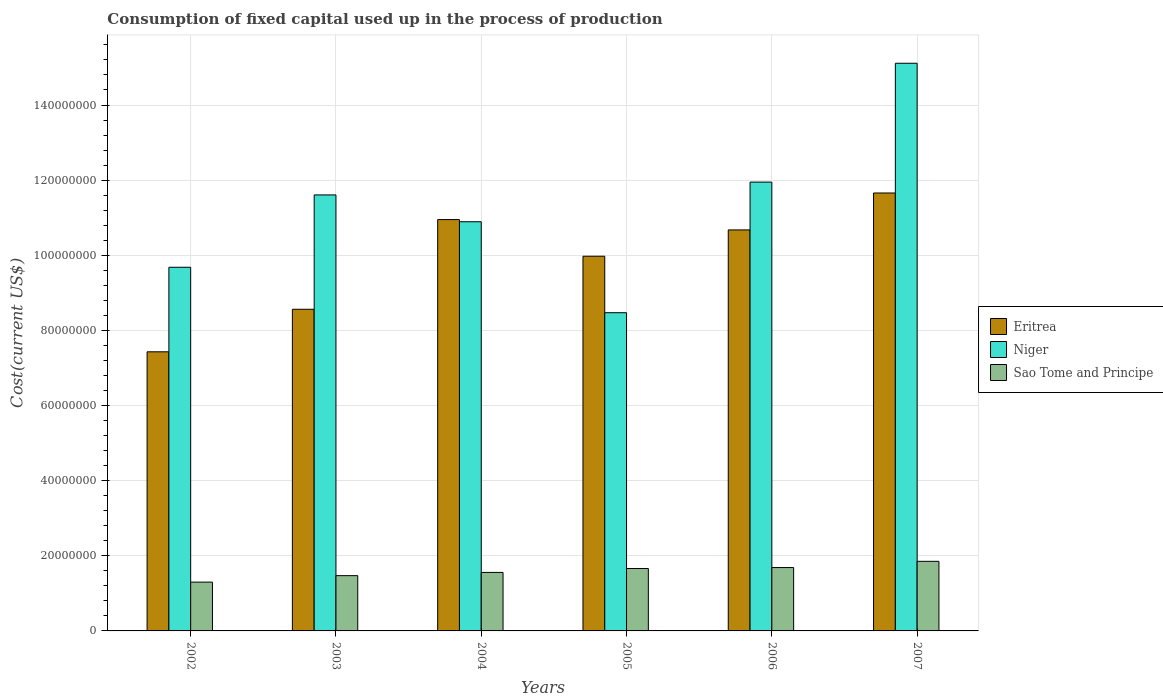How many bars are there on the 4th tick from the left?
Provide a succinct answer. 3. In how many cases, is the number of bars for a given year not equal to the number of legend labels?
Give a very brief answer. 0. What is the amount consumed in the process of production in Eritrea in 2002?
Provide a short and direct response. 7.43e+07. Across all years, what is the maximum amount consumed in the process of production in Eritrea?
Provide a short and direct response. 1.17e+08. Across all years, what is the minimum amount consumed in the process of production in Niger?
Offer a terse response. 8.47e+07. What is the total amount consumed in the process of production in Eritrea in the graph?
Ensure brevity in your answer.  5.93e+08. What is the difference between the amount consumed in the process of production in Sao Tome and Principe in 2005 and that in 2007?
Your answer should be compact. -1.92e+06. What is the difference between the amount consumed in the process of production in Eritrea in 2006 and the amount consumed in the process of production in Niger in 2004?
Offer a terse response. -2.17e+06. What is the average amount consumed in the process of production in Niger per year?
Offer a terse response. 1.13e+08. In the year 2003, what is the difference between the amount consumed in the process of production in Niger and amount consumed in the process of production in Sao Tome and Principe?
Your answer should be compact. 1.01e+08. In how many years, is the amount consumed in the process of production in Niger greater than 72000000 US$?
Your answer should be compact. 6. What is the ratio of the amount consumed in the process of production in Niger in 2004 to that in 2007?
Offer a terse response. 0.72. Is the amount consumed in the process of production in Niger in 2003 less than that in 2006?
Your answer should be very brief. Yes. Is the difference between the amount consumed in the process of production in Niger in 2003 and 2007 greater than the difference between the amount consumed in the process of production in Sao Tome and Principe in 2003 and 2007?
Keep it short and to the point. No. What is the difference between the highest and the second highest amount consumed in the process of production in Sao Tome and Principe?
Your answer should be compact. 1.66e+06. What is the difference between the highest and the lowest amount consumed in the process of production in Eritrea?
Ensure brevity in your answer.  4.23e+07. In how many years, is the amount consumed in the process of production in Eritrea greater than the average amount consumed in the process of production in Eritrea taken over all years?
Offer a terse response. 4. Is the sum of the amount consumed in the process of production in Sao Tome and Principe in 2002 and 2007 greater than the maximum amount consumed in the process of production in Niger across all years?
Your answer should be compact. No. What does the 3rd bar from the left in 2005 represents?
Make the answer very short. Sao Tome and Principe. What does the 2nd bar from the right in 2004 represents?
Provide a succinct answer. Niger. Is it the case that in every year, the sum of the amount consumed in the process of production in Eritrea and amount consumed in the process of production in Sao Tome and Principe is greater than the amount consumed in the process of production in Niger?
Keep it short and to the point. No. How many years are there in the graph?
Give a very brief answer. 6. Are the values on the major ticks of Y-axis written in scientific E-notation?
Give a very brief answer. No. Does the graph contain grids?
Offer a terse response. Yes. How many legend labels are there?
Offer a very short reply. 3. What is the title of the graph?
Give a very brief answer. Consumption of fixed capital used up in the process of production. Does "Kosovo" appear as one of the legend labels in the graph?
Your answer should be very brief. No. What is the label or title of the X-axis?
Keep it short and to the point. Years. What is the label or title of the Y-axis?
Ensure brevity in your answer.  Cost(current US$). What is the Cost(current US$) of Eritrea in 2002?
Make the answer very short. 7.43e+07. What is the Cost(current US$) of Niger in 2002?
Keep it short and to the point. 9.68e+07. What is the Cost(current US$) of Sao Tome and Principe in 2002?
Keep it short and to the point. 1.30e+07. What is the Cost(current US$) of Eritrea in 2003?
Your answer should be very brief. 8.56e+07. What is the Cost(current US$) in Niger in 2003?
Provide a succinct answer. 1.16e+08. What is the Cost(current US$) in Sao Tome and Principe in 2003?
Give a very brief answer. 1.47e+07. What is the Cost(current US$) of Eritrea in 2004?
Your answer should be compact. 1.10e+08. What is the Cost(current US$) of Niger in 2004?
Your answer should be compact. 1.09e+08. What is the Cost(current US$) of Sao Tome and Principe in 2004?
Provide a succinct answer. 1.56e+07. What is the Cost(current US$) of Eritrea in 2005?
Your answer should be very brief. 9.97e+07. What is the Cost(current US$) of Niger in 2005?
Keep it short and to the point. 8.47e+07. What is the Cost(current US$) in Sao Tome and Principe in 2005?
Keep it short and to the point. 1.66e+07. What is the Cost(current US$) in Eritrea in 2006?
Offer a terse response. 1.07e+08. What is the Cost(current US$) of Niger in 2006?
Your answer should be very brief. 1.19e+08. What is the Cost(current US$) in Sao Tome and Principe in 2006?
Your answer should be very brief. 1.69e+07. What is the Cost(current US$) in Eritrea in 2007?
Make the answer very short. 1.17e+08. What is the Cost(current US$) of Niger in 2007?
Give a very brief answer. 1.51e+08. What is the Cost(current US$) in Sao Tome and Principe in 2007?
Keep it short and to the point. 1.85e+07. Across all years, what is the maximum Cost(current US$) in Eritrea?
Keep it short and to the point. 1.17e+08. Across all years, what is the maximum Cost(current US$) of Niger?
Your response must be concise. 1.51e+08. Across all years, what is the maximum Cost(current US$) of Sao Tome and Principe?
Give a very brief answer. 1.85e+07. Across all years, what is the minimum Cost(current US$) of Eritrea?
Offer a terse response. 7.43e+07. Across all years, what is the minimum Cost(current US$) of Niger?
Offer a terse response. 8.47e+07. Across all years, what is the minimum Cost(current US$) in Sao Tome and Principe?
Keep it short and to the point. 1.30e+07. What is the total Cost(current US$) of Eritrea in the graph?
Offer a very short reply. 5.93e+08. What is the total Cost(current US$) of Niger in the graph?
Your response must be concise. 6.77e+08. What is the total Cost(current US$) in Sao Tome and Principe in the graph?
Your answer should be compact. 9.53e+07. What is the difference between the Cost(current US$) in Eritrea in 2002 and that in 2003?
Your answer should be very brief. -1.13e+07. What is the difference between the Cost(current US$) in Niger in 2002 and that in 2003?
Your answer should be compact. -1.93e+07. What is the difference between the Cost(current US$) of Sao Tome and Principe in 2002 and that in 2003?
Your answer should be very brief. -1.72e+06. What is the difference between the Cost(current US$) in Eritrea in 2002 and that in 2004?
Provide a short and direct response. -3.52e+07. What is the difference between the Cost(current US$) of Niger in 2002 and that in 2004?
Your answer should be compact. -1.21e+07. What is the difference between the Cost(current US$) of Sao Tome and Principe in 2002 and that in 2004?
Give a very brief answer. -2.58e+06. What is the difference between the Cost(current US$) of Eritrea in 2002 and that in 2005?
Offer a terse response. -2.54e+07. What is the difference between the Cost(current US$) in Niger in 2002 and that in 2005?
Provide a short and direct response. 1.21e+07. What is the difference between the Cost(current US$) in Sao Tome and Principe in 2002 and that in 2005?
Your answer should be very brief. -3.62e+06. What is the difference between the Cost(current US$) in Eritrea in 2002 and that in 2006?
Your answer should be very brief. -3.25e+07. What is the difference between the Cost(current US$) of Niger in 2002 and that in 2006?
Your response must be concise. -2.27e+07. What is the difference between the Cost(current US$) of Sao Tome and Principe in 2002 and that in 2006?
Provide a succinct answer. -3.87e+06. What is the difference between the Cost(current US$) in Eritrea in 2002 and that in 2007?
Your response must be concise. -4.23e+07. What is the difference between the Cost(current US$) in Niger in 2002 and that in 2007?
Provide a short and direct response. -5.43e+07. What is the difference between the Cost(current US$) of Sao Tome and Principe in 2002 and that in 2007?
Your answer should be very brief. -5.54e+06. What is the difference between the Cost(current US$) in Eritrea in 2003 and that in 2004?
Make the answer very short. -2.39e+07. What is the difference between the Cost(current US$) in Niger in 2003 and that in 2004?
Give a very brief answer. 7.14e+06. What is the difference between the Cost(current US$) of Sao Tome and Principe in 2003 and that in 2004?
Provide a short and direct response. -8.62e+05. What is the difference between the Cost(current US$) in Eritrea in 2003 and that in 2005?
Give a very brief answer. -1.41e+07. What is the difference between the Cost(current US$) in Niger in 2003 and that in 2005?
Provide a short and direct response. 3.14e+07. What is the difference between the Cost(current US$) in Sao Tome and Principe in 2003 and that in 2005?
Provide a succinct answer. -1.90e+06. What is the difference between the Cost(current US$) of Eritrea in 2003 and that in 2006?
Ensure brevity in your answer.  -2.11e+07. What is the difference between the Cost(current US$) of Niger in 2003 and that in 2006?
Provide a succinct answer. -3.42e+06. What is the difference between the Cost(current US$) of Sao Tome and Principe in 2003 and that in 2006?
Keep it short and to the point. -2.15e+06. What is the difference between the Cost(current US$) of Eritrea in 2003 and that in 2007?
Give a very brief answer. -3.10e+07. What is the difference between the Cost(current US$) in Niger in 2003 and that in 2007?
Your response must be concise. -3.51e+07. What is the difference between the Cost(current US$) in Sao Tome and Principe in 2003 and that in 2007?
Your answer should be very brief. -3.81e+06. What is the difference between the Cost(current US$) in Eritrea in 2004 and that in 2005?
Provide a short and direct response. 9.75e+06. What is the difference between the Cost(current US$) in Niger in 2004 and that in 2005?
Your answer should be compact. 2.42e+07. What is the difference between the Cost(current US$) in Sao Tome and Principe in 2004 and that in 2005?
Your answer should be compact. -1.04e+06. What is the difference between the Cost(current US$) of Eritrea in 2004 and that in 2006?
Your response must be concise. 2.75e+06. What is the difference between the Cost(current US$) of Niger in 2004 and that in 2006?
Your answer should be compact. -1.06e+07. What is the difference between the Cost(current US$) in Sao Tome and Principe in 2004 and that in 2006?
Make the answer very short. -1.29e+06. What is the difference between the Cost(current US$) of Eritrea in 2004 and that in 2007?
Your answer should be compact. -7.08e+06. What is the difference between the Cost(current US$) in Niger in 2004 and that in 2007?
Provide a succinct answer. -4.22e+07. What is the difference between the Cost(current US$) in Sao Tome and Principe in 2004 and that in 2007?
Give a very brief answer. -2.95e+06. What is the difference between the Cost(current US$) of Eritrea in 2005 and that in 2006?
Make the answer very short. -7.01e+06. What is the difference between the Cost(current US$) of Niger in 2005 and that in 2006?
Ensure brevity in your answer.  -3.48e+07. What is the difference between the Cost(current US$) of Sao Tome and Principe in 2005 and that in 2006?
Make the answer very short. -2.56e+05. What is the difference between the Cost(current US$) in Eritrea in 2005 and that in 2007?
Offer a very short reply. -1.68e+07. What is the difference between the Cost(current US$) in Niger in 2005 and that in 2007?
Keep it short and to the point. -6.64e+07. What is the difference between the Cost(current US$) of Sao Tome and Principe in 2005 and that in 2007?
Your answer should be very brief. -1.92e+06. What is the difference between the Cost(current US$) in Eritrea in 2006 and that in 2007?
Your answer should be compact. -9.83e+06. What is the difference between the Cost(current US$) of Niger in 2006 and that in 2007?
Give a very brief answer. -3.16e+07. What is the difference between the Cost(current US$) of Sao Tome and Principe in 2006 and that in 2007?
Your response must be concise. -1.66e+06. What is the difference between the Cost(current US$) of Eritrea in 2002 and the Cost(current US$) of Niger in 2003?
Give a very brief answer. -4.18e+07. What is the difference between the Cost(current US$) in Eritrea in 2002 and the Cost(current US$) in Sao Tome and Principe in 2003?
Ensure brevity in your answer.  5.96e+07. What is the difference between the Cost(current US$) in Niger in 2002 and the Cost(current US$) in Sao Tome and Principe in 2003?
Offer a very short reply. 8.21e+07. What is the difference between the Cost(current US$) in Eritrea in 2002 and the Cost(current US$) in Niger in 2004?
Ensure brevity in your answer.  -3.46e+07. What is the difference between the Cost(current US$) in Eritrea in 2002 and the Cost(current US$) in Sao Tome and Principe in 2004?
Provide a succinct answer. 5.87e+07. What is the difference between the Cost(current US$) in Niger in 2002 and the Cost(current US$) in Sao Tome and Principe in 2004?
Provide a succinct answer. 8.12e+07. What is the difference between the Cost(current US$) in Eritrea in 2002 and the Cost(current US$) in Niger in 2005?
Offer a terse response. -1.04e+07. What is the difference between the Cost(current US$) of Eritrea in 2002 and the Cost(current US$) of Sao Tome and Principe in 2005?
Your answer should be very brief. 5.77e+07. What is the difference between the Cost(current US$) of Niger in 2002 and the Cost(current US$) of Sao Tome and Principe in 2005?
Provide a short and direct response. 8.02e+07. What is the difference between the Cost(current US$) of Eritrea in 2002 and the Cost(current US$) of Niger in 2006?
Your response must be concise. -4.52e+07. What is the difference between the Cost(current US$) of Eritrea in 2002 and the Cost(current US$) of Sao Tome and Principe in 2006?
Your response must be concise. 5.74e+07. What is the difference between the Cost(current US$) in Niger in 2002 and the Cost(current US$) in Sao Tome and Principe in 2006?
Offer a terse response. 7.99e+07. What is the difference between the Cost(current US$) of Eritrea in 2002 and the Cost(current US$) of Niger in 2007?
Your response must be concise. -7.68e+07. What is the difference between the Cost(current US$) in Eritrea in 2002 and the Cost(current US$) in Sao Tome and Principe in 2007?
Keep it short and to the point. 5.58e+07. What is the difference between the Cost(current US$) of Niger in 2002 and the Cost(current US$) of Sao Tome and Principe in 2007?
Offer a very short reply. 7.83e+07. What is the difference between the Cost(current US$) in Eritrea in 2003 and the Cost(current US$) in Niger in 2004?
Make the answer very short. -2.33e+07. What is the difference between the Cost(current US$) in Eritrea in 2003 and the Cost(current US$) in Sao Tome and Principe in 2004?
Provide a succinct answer. 7.01e+07. What is the difference between the Cost(current US$) of Niger in 2003 and the Cost(current US$) of Sao Tome and Principe in 2004?
Your response must be concise. 1.00e+08. What is the difference between the Cost(current US$) in Eritrea in 2003 and the Cost(current US$) in Niger in 2005?
Make the answer very short. 9.17e+05. What is the difference between the Cost(current US$) of Eritrea in 2003 and the Cost(current US$) of Sao Tome and Principe in 2005?
Offer a terse response. 6.90e+07. What is the difference between the Cost(current US$) in Niger in 2003 and the Cost(current US$) in Sao Tome and Principe in 2005?
Offer a terse response. 9.95e+07. What is the difference between the Cost(current US$) in Eritrea in 2003 and the Cost(current US$) in Niger in 2006?
Make the answer very short. -3.39e+07. What is the difference between the Cost(current US$) of Eritrea in 2003 and the Cost(current US$) of Sao Tome and Principe in 2006?
Provide a succinct answer. 6.88e+07. What is the difference between the Cost(current US$) of Niger in 2003 and the Cost(current US$) of Sao Tome and Principe in 2006?
Make the answer very short. 9.92e+07. What is the difference between the Cost(current US$) of Eritrea in 2003 and the Cost(current US$) of Niger in 2007?
Your answer should be compact. -6.55e+07. What is the difference between the Cost(current US$) of Eritrea in 2003 and the Cost(current US$) of Sao Tome and Principe in 2007?
Your answer should be compact. 6.71e+07. What is the difference between the Cost(current US$) of Niger in 2003 and the Cost(current US$) of Sao Tome and Principe in 2007?
Provide a succinct answer. 9.75e+07. What is the difference between the Cost(current US$) in Eritrea in 2004 and the Cost(current US$) in Niger in 2005?
Keep it short and to the point. 2.48e+07. What is the difference between the Cost(current US$) of Eritrea in 2004 and the Cost(current US$) of Sao Tome and Principe in 2005?
Your answer should be compact. 9.29e+07. What is the difference between the Cost(current US$) of Niger in 2004 and the Cost(current US$) of Sao Tome and Principe in 2005?
Ensure brevity in your answer.  9.23e+07. What is the difference between the Cost(current US$) in Eritrea in 2004 and the Cost(current US$) in Niger in 2006?
Your answer should be compact. -9.98e+06. What is the difference between the Cost(current US$) in Eritrea in 2004 and the Cost(current US$) in Sao Tome and Principe in 2006?
Ensure brevity in your answer.  9.26e+07. What is the difference between the Cost(current US$) in Niger in 2004 and the Cost(current US$) in Sao Tome and Principe in 2006?
Offer a terse response. 9.21e+07. What is the difference between the Cost(current US$) of Eritrea in 2004 and the Cost(current US$) of Niger in 2007?
Your answer should be very brief. -4.16e+07. What is the difference between the Cost(current US$) in Eritrea in 2004 and the Cost(current US$) in Sao Tome and Principe in 2007?
Offer a terse response. 9.10e+07. What is the difference between the Cost(current US$) of Niger in 2004 and the Cost(current US$) of Sao Tome and Principe in 2007?
Keep it short and to the point. 9.04e+07. What is the difference between the Cost(current US$) in Eritrea in 2005 and the Cost(current US$) in Niger in 2006?
Make the answer very short. -1.97e+07. What is the difference between the Cost(current US$) in Eritrea in 2005 and the Cost(current US$) in Sao Tome and Principe in 2006?
Ensure brevity in your answer.  8.29e+07. What is the difference between the Cost(current US$) in Niger in 2005 and the Cost(current US$) in Sao Tome and Principe in 2006?
Your response must be concise. 6.78e+07. What is the difference between the Cost(current US$) in Eritrea in 2005 and the Cost(current US$) in Niger in 2007?
Make the answer very short. -5.14e+07. What is the difference between the Cost(current US$) of Eritrea in 2005 and the Cost(current US$) of Sao Tome and Principe in 2007?
Keep it short and to the point. 8.12e+07. What is the difference between the Cost(current US$) in Niger in 2005 and the Cost(current US$) in Sao Tome and Principe in 2007?
Your answer should be very brief. 6.62e+07. What is the difference between the Cost(current US$) in Eritrea in 2006 and the Cost(current US$) in Niger in 2007?
Your answer should be compact. -4.44e+07. What is the difference between the Cost(current US$) of Eritrea in 2006 and the Cost(current US$) of Sao Tome and Principe in 2007?
Offer a very short reply. 8.82e+07. What is the difference between the Cost(current US$) in Niger in 2006 and the Cost(current US$) in Sao Tome and Principe in 2007?
Your answer should be very brief. 1.01e+08. What is the average Cost(current US$) of Eritrea per year?
Offer a very short reply. 9.88e+07. What is the average Cost(current US$) in Niger per year?
Your answer should be compact. 1.13e+08. What is the average Cost(current US$) in Sao Tome and Principe per year?
Offer a very short reply. 1.59e+07. In the year 2002, what is the difference between the Cost(current US$) of Eritrea and Cost(current US$) of Niger?
Ensure brevity in your answer.  -2.25e+07. In the year 2002, what is the difference between the Cost(current US$) of Eritrea and Cost(current US$) of Sao Tome and Principe?
Ensure brevity in your answer.  6.13e+07. In the year 2002, what is the difference between the Cost(current US$) of Niger and Cost(current US$) of Sao Tome and Principe?
Ensure brevity in your answer.  8.38e+07. In the year 2003, what is the difference between the Cost(current US$) in Eritrea and Cost(current US$) in Niger?
Your answer should be compact. -3.04e+07. In the year 2003, what is the difference between the Cost(current US$) in Eritrea and Cost(current US$) in Sao Tome and Principe?
Your response must be concise. 7.09e+07. In the year 2003, what is the difference between the Cost(current US$) of Niger and Cost(current US$) of Sao Tome and Principe?
Ensure brevity in your answer.  1.01e+08. In the year 2004, what is the difference between the Cost(current US$) of Eritrea and Cost(current US$) of Niger?
Provide a succinct answer. 5.76e+05. In the year 2004, what is the difference between the Cost(current US$) of Eritrea and Cost(current US$) of Sao Tome and Principe?
Your answer should be very brief. 9.39e+07. In the year 2004, what is the difference between the Cost(current US$) of Niger and Cost(current US$) of Sao Tome and Principe?
Your response must be concise. 9.34e+07. In the year 2005, what is the difference between the Cost(current US$) of Eritrea and Cost(current US$) of Niger?
Your response must be concise. 1.50e+07. In the year 2005, what is the difference between the Cost(current US$) in Eritrea and Cost(current US$) in Sao Tome and Principe?
Your answer should be very brief. 8.31e+07. In the year 2005, what is the difference between the Cost(current US$) in Niger and Cost(current US$) in Sao Tome and Principe?
Make the answer very short. 6.81e+07. In the year 2006, what is the difference between the Cost(current US$) in Eritrea and Cost(current US$) in Niger?
Offer a terse response. -1.27e+07. In the year 2006, what is the difference between the Cost(current US$) of Eritrea and Cost(current US$) of Sao Tome and Principe?
Your answer should be very brief. 8.99e+07. In the year 2006, what is the difference between the Cost(current US$) in Niger and Cost(current US$) in Sao Tome and Principe?
Your answer should be compact. 1.03e+08. In the year 2007, what is the difference between the Cost(current US$) of Eritrea and Cost(current US$) of Niger?
Your answer should be very brief. -3.45e+07. In the year 2007, what is the difference between the Cost(current US$) of Eritrea and Cost(current US$) of Sao Tome and Principe?
Ensure brevity in your answer.  9.81e+07. In the year 2007, what is the difference between the Cost(current US$) of Niger and Cost(current US$) of Sao Tome and Principe?
Your response must be concise. 1.33e+08. What is the ratio of the Cost(current US$) of Eritrea in 2002 to that in 2003?
Keep it short and to the point. 0.87. What is the ratio of the Cost(current US$) in Niger in 2002 to that in 2003?
Your answer should be very brief. 0.83. What is the ratio of the Cost(current US$) of Sao Tome and Principe in 2002 to that in 2003?
Offer a very short reply. 0.88. What is the ratio of the Cost(current US$) of Eritrea in 2002 to that in 2004?
Keep it short and to the point. 0.68. What is the ratio of the Cost(current US$) in Niger in 2002 to that in 2004?
Offer a very short reply. 0.89. What is the ratio of the Cost(current US$) in Sao Tome and Principe in 2002 to that in 2004?
Offer a very short reply. 0.83. What is the ratio of the Cost(current US$) in Eritrea in 2002 to that in 2005?
Make the answer very short. 0.74. What is the ratio of the Cost(current US$) of Niger in 2002 to that in 2005?
Offer a very short reply. 1.14. What is the ratio of the Cost(current US$) of Sao Tome and Principe in 2002 to that in 2005?
Ensure brevity in your answer.  0.78. What is the ratio of the Cost(current US$) in Eritrea in 2002 to that in 2006?
Provide a succinct answer. 0.7. What is the ratio of the Cost(current US$) in Niger in 2002 to that in 2006?
Make the answer very short. 0.81. What is the ratio of the Cost(current US$) of Sao Tome and Principe in 2002 to that in 2006?
Ensure brevity in your answer.  0.77. What is the ratio of the Cost(current US$) of Eritrea in 2002 to that in 2007?
Provide a succinct answer. 0.64. What is the ratio of the Cost(current US$) of Niger in 2002 to that in 2007?
Make the answer very short. 0.64. What is the ratio of the Cost(current US$) of Sao Tome and Principe in 2002 to that in 2007?
Ensure brevity in your answer.  0.7. What is the ratio of the Cost(current US$) of Eritrea in 2003 to that in 2004?
Offer a very short reply. 0.78. What is the ratio of the Cost(current US$) in Niger in 2003 to that in 2004?
Make the answer very short. 1.07. What is the ratio of the Cost(current US$) of Sao Tome and Principe in 2003 to that in 2004?
Provide a short and direct response. 0.94. What is the ratio of the Cost(current US$) of Eritrea in 2003 to that in 2005?
Provide a short and direct response. 0.86. What is the ratio of the Cost(current US$) in Niger in 2003 to that in 2005?
Your response must be concise. 1.37. What is the ratio of the Cost(current US$) in Sao Tome and Principe in 2003 to that in 2005?
Ensure brevity in your answer.  0.89. What is the ratio of the Cost(current US$) in Eritrea in 2003 to that in 2006?
Make the answer very short. 0.8. What is the ratio of the Cost(current US$) in Niger in 2003 to that in 2006?
Provide a succinct answer. 0.97. What is the ratio of the Cost(current US$) of Sao Tome and Principe in 2003 to that in 2006?
Offer a very short reply. 0.87. What is the ratio of the Cost(current US$) of Eritrea in 2003 to that in 2007?
Your answer should be compact. 0.73. What is the ratio of the Cost(current US$) of Niger in 2003 to that in 2007?
Provide a short and direct response. 0.77. What is the ratio of the Cost(current US$) of Sao Tome and Principe in 2003 to that in 2007?
Provide a short and direct response. 0.79. What is the ratio of the Cost(current US$) in Eritrea in 2004 to that in 2005?
Your answer should be very brief. 1.1. What is the ratio of the Cost(current US$) in Niger in 2004 to that in 2005?
Keep it short and to the point. 1.29. What is the ratio of the Cost(current US$) of Sao Tome and Principe in 2004 to that in 2005?
Offer a very short reply. 0.94. What is the ratio of the Cost(current US$) of Eritrea in 2004 to that in 2006?
Make the answer very short. 1.03. What is the ratio of the Cost(current US$) of Niger in 2004 to that in 2006?
Give a very brief answer. 0.91. What is the ratio of the Cost(current US$) in Sao Tome and Principe in 2004 to that in 2006?
Your answer should be compact. 0.92. What is the ratio of the Cost(current US$) of Eritrea in 2004 to that in 2007?
Provide a succinct answer. 0.94. What is the ratio of the Cost(current US$) in Niger in 2004 to that in 2007?
Provide a succinct answer. 0.72. What is the ratio of the Cost(current US$) of Sao Tome and Principe in 2004 to that in 2007?
Offer a very short reply. 0.84. What is the ratio of the Cost(current US$) in Eritrea in 2005 to that in 2006?
Provide a succinct answer. 0.93. What is the ratio of the Cost(current US$) of Niger in 2005 to that in 2006?
Give a very brief answer. 0.71. What is the ratio of the Cost(current US$) in Sao Tome and Principe in 2005 to that in 2006?
Provide a succinct answer. 0.98. What is the ratio of the Cost(current US$) in Eritrea in 2005 to that in 2007?
Keep it short and to the point. 0.86. What is the ratio of the Cost(current US$) of Niger in 2005 to that in 2007?
Offer a terse response. 0.56. What is the ratio of the Cost(current US$) in Sao Tome and Principe in 2005 to that in 2007?
Provide a short and direct response. 0.9. What is the ratio of the Cost(current US$) in Eritrea in 2006 to that in 2007?
Provide a short and direct response. 0.92. What is the ratio of the Cost(current US$) in Niger in 2006 to that in 2007?
Keep it short and to the point. 0.79. What is the ratio of the Cost(current US$) in Sao Tome and Principe in 2006 to that in 2007?
Your response must be concise. 0.91. What is the difference between the highest and the second highest Cost(current US$) of Eritrea?
Your answer should be compact. 7.08e+06. What is the difference between the highest and the second highest Cost(current US$) of Niger?
Make the answer very short. 3.16e+07. What is the difference between the highest and the second highest Cost(current US$) of Sao Tome and Principe?
Make the answer very short. 1.66e+06. What is the difference between the highest and the lowest Cost(current US$) in Eritrea?
Make the answer very short. 4.23e+07. What is the difference between the highest and the lowest Cost(current US$) of Niger?
Your response must be concise. 6.64e+07. What is the difference between the highest and the lowest Cost(current US$) of Sao Tome and Principe?
Provide a succinct answer. 5.54e+06. 